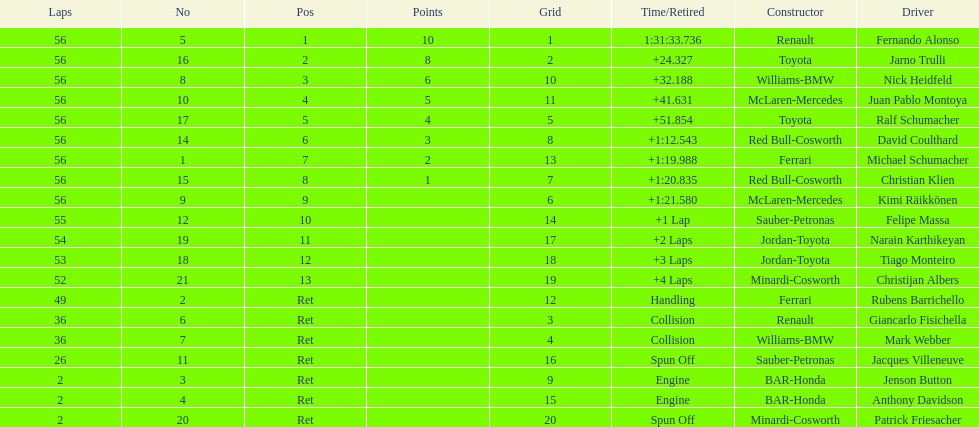What were the total number of laps completed by the 1st position winner? 56. 